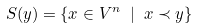<formula> <loc_0><loc_0><loc_500><loc_500>S ( y ) = \{ x \in V ^ { n } \ | \ x \prec y \}</formula> 